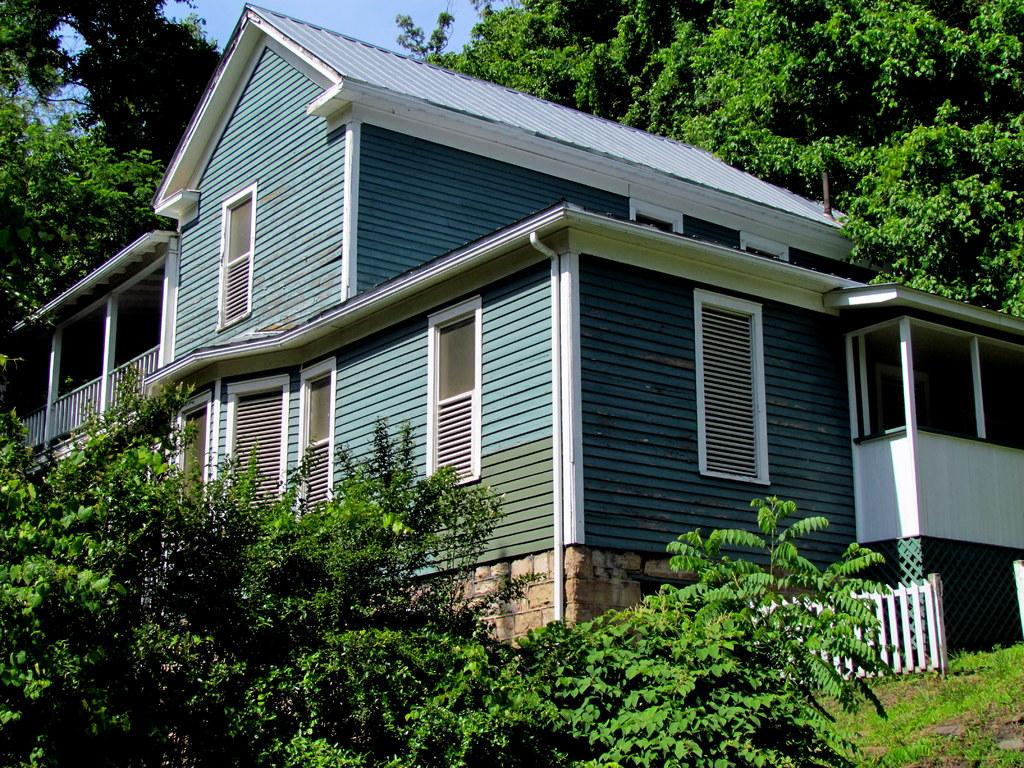What type of vegetation can be seen in the image? There are plants in the image. What type of barrier is present in the image? There is a wooden fence in the image. What type of structure can be seen in the image? There is a stone wall and a wooden house in the image. What can be seen in the background of the image? There are trees and the sky visible in the background of the image. Can you tell me how many rays are visible in the image? There are no rays present in the image; it features plants, a wooden fence, a stone wall, a wooden house, trees, and the sky. What type of hall is depicted in the image? There is no hall depicted in the image. 